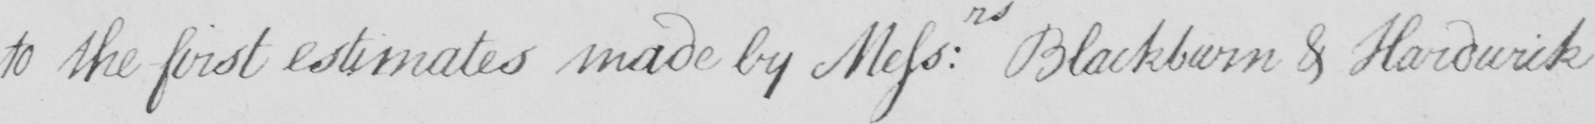Can you tell me what this handwritten text says? to the first estimates made by Mess : rs Blackburn & Hardwick 